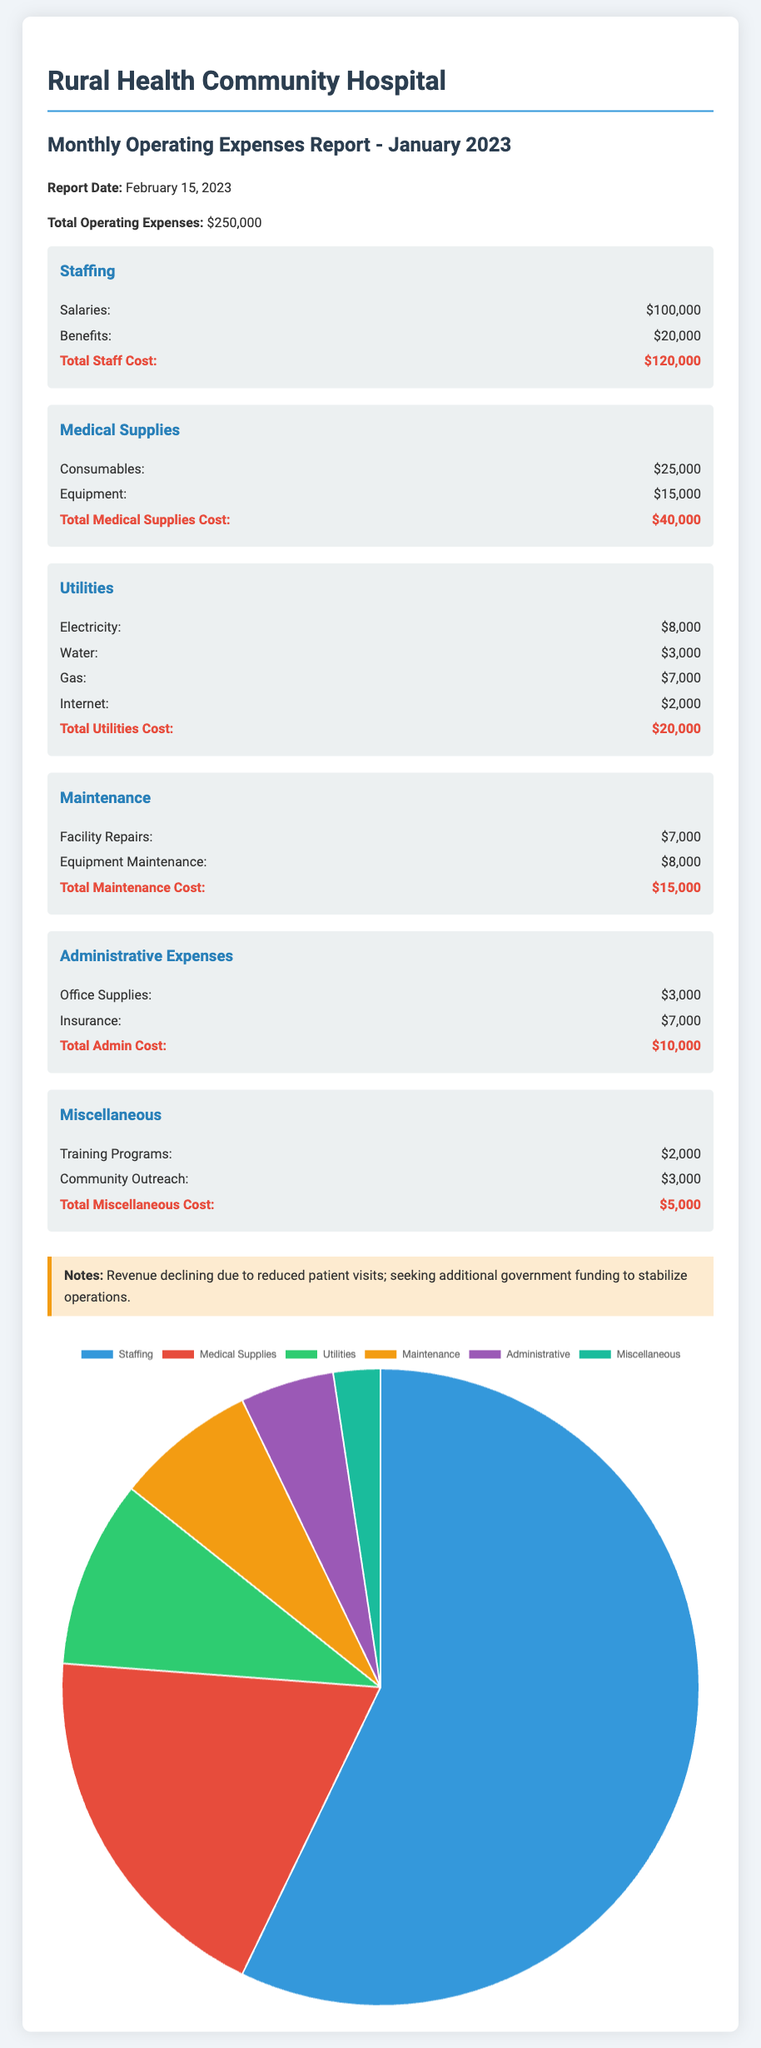what is the total operating expenses? The total operating expenses are explicitly stated in the document, which indicates all costs incurred in January 2023.
Answer: $250,000 how much was spent on staffing? Staffing expenses are broken down into salaries and benefits in the document, and their sum gives the total staffing cost.
Answer: $120,000 what is the cost of medical supplies? The document lists both consumables and equipment costs under medical supplies, which are added together to find the total.
Answer: $40,000 how much was spent on utilities? Utilities costs are provided separately for electricity, water, gas, and internet, which combine to produce the total utilities expenses.
Answer: $20,000 what is the total cost of maintenance? The maintenance section details costs for facility repairs and equipment maintenance, from which the total maintenance cost is calculated.
Answer: $15,000 what were the administrative expenses? Administrative expenses include office supplies and insurance, both of which are itemized in the report. Their sum represents the total admin cost.
Answer: $10,000 how much was allocated for community outreach? The document indicates a specific amount spent on community outreach, cited under miscellaneous expenses.
Answer: $3,000 what is noted about revenue in the document? The notes section provides insights about revenue trends affecting the hospital's funding, reflecting changing financial conditions.
Answer: Declining due to reduced patient visits what type of chart is used to represent the expenses? The document includes a pie chart that visually details the distribution of various expense categories.
Answer: Pie chart 